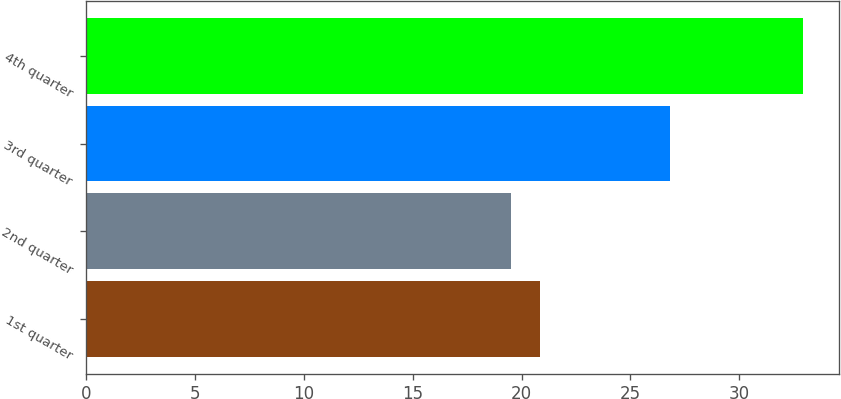Convert chart. <chart><loc_0><loc_0><loc_500><loc_500><bar_chart><fcel>1st quarter<fcel>2nd quarter<fcel>3rd quarter<fcel>4th quarter<nl><fcel>20.86<fcel>19.52<fcel>26.83<fcel>32.95<nl></chart> 